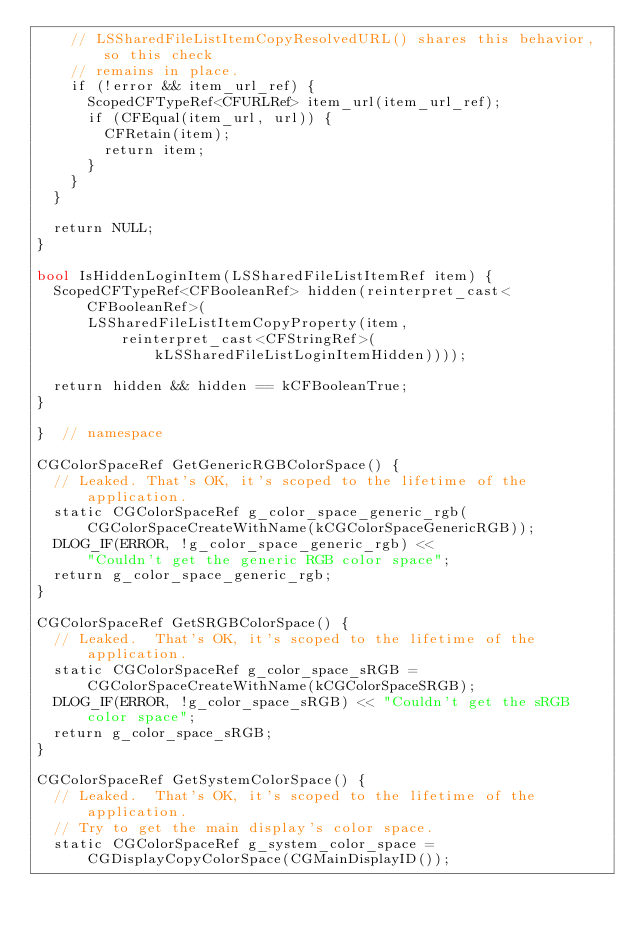<code> <loc_0><loc_0><loc_500><loc_500><_ObjectiveC_>    // LSSharedFileListItemCopyResolvedURL() shares this behavior, so this check
    // remains in place.
    if (!error && item_url_ref) {
      ScopedCFTypeRef<CFURLRef> item_url(item_url_ref);
      if (CFEqual(item_url, url)) {
        CFRetain(item);
        return item;
      }
    }
  }

  return NULL;
}

bool IsHiddenLoginItem(LSSharedFileListItemRef item) {
  ScopedCFTypeRef<CFBooleanRef> hidden(reinterpret_cast<CFBooleanRef>(
      LSSharedFileListItemCopyProperty(item,
          reinterpret_cast<CFStringRef>(kLSSharedFileListLoginItemHidden))));

  return hidden && hidden == kCFBooleanTrue;
}

}  // namespace

CGColorSpaceRef GetGenericRGBColorSpace() {
  // Leaked. That's OK, it's scoped to the lifetime of the application.
  static CGColorSpaceRef g_color_space_generic_rgb(
      CGColorSpaceCreateWithName(kCGColorSpaceGenericRGB));
  DLOG_IF(ERROR, !g_color_space_generic_rgb) <<
      "Couldn't get the generic RGB color space";
  return g_color_space_generic_rgb;
}

CGColorSpaceRef GetSRGBColorSpace() {
  // Leaked.  That's OK, it's scoped to the lifetime of the application.
  static CGColorSpaceRef g_color_space_sRGB =
      CGColorSpaceCreateWithName(kCGColorSpaceSRGB);
  DLOG_IF(ERROR, !g_color_space_sRGB) << "Couldn't get the sRGB color space";
  return g_color_space_sRGB;
}

CGColorSpaceRef GetSystemColorSpace() {
  // Leaked.  That's OK, it's scoped to the lifetime of the application.
  // Try to get the main display's color space.
  static CGColorSpaceRef g_system_color_space =
      CGDisplayCopyColorSpace(CGMainDisplayID());
</code> 